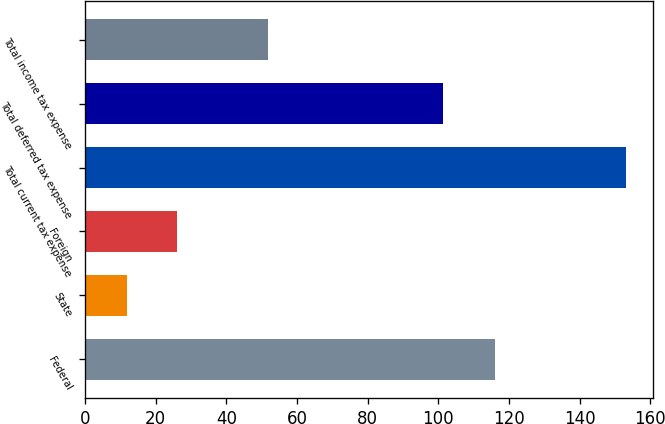Convert chart. <chart><loc_0><loc_0><loc_500><loc_500><bar_chart><fcel>Federal<fcel>State<fcel>Foreign<fcel>Total current tax expense<fcel>Total deferred tax expense<fcel>Total income tax expense<nl><fcel>116.1<fcel>11.8<fcel>25.93<fcel>153.1<fcel>101.3<fcel>51.8<nl></chart> 